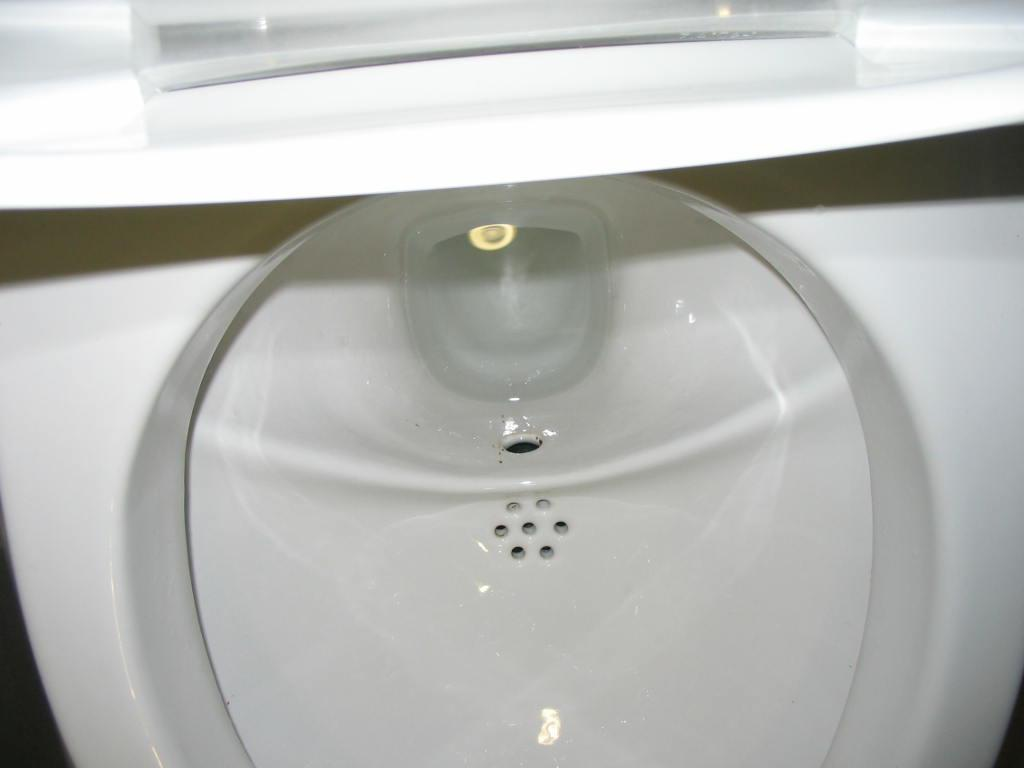What type of furniture is present in the image? There is a commode in the image. What color is the commode? The commode is white in color. What type of toys can be seen on the commode in the image? There are no toys present on the commode in the image. 